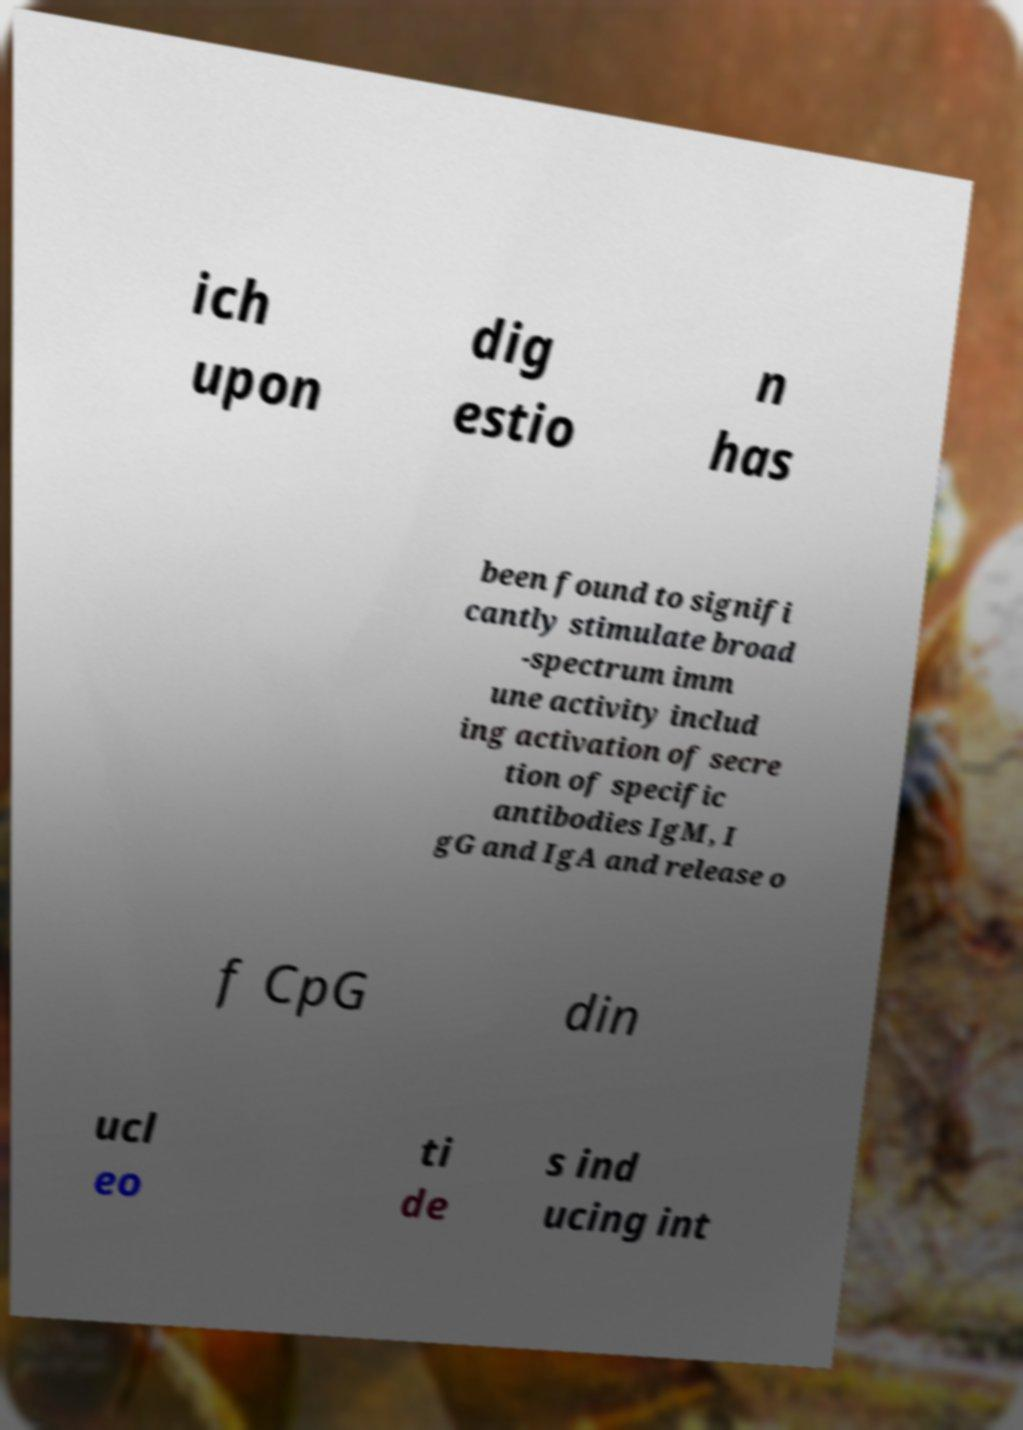Please identify and transcribe the text found in this image. ich upon dig estio n has been found to signifi cantly stimulate broad -spectrum imm une activity includ ing activation of secre tion of specific antibodies IgM, I gG and IgA and release o f CpG din ucl eo ti de s ind ucing int 